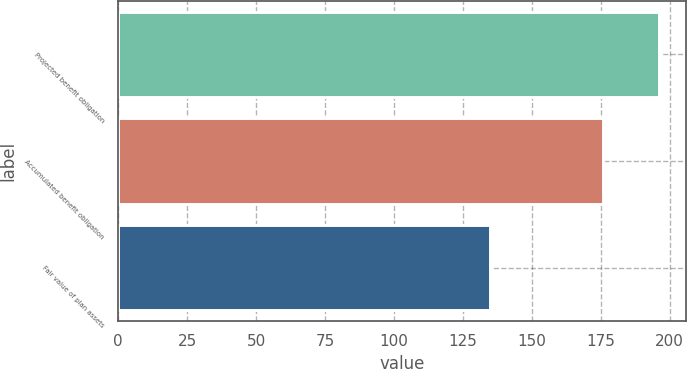<chart> <loc_0><loc_0><loc_500><loc_500><bar_chart><fcel>Projected benefit obligation<fcel>Accumulated benefit obligation<fcel>Fair value of plan assets<nl><fcel>196<fcel>176<fcel>135<nl></chart> 